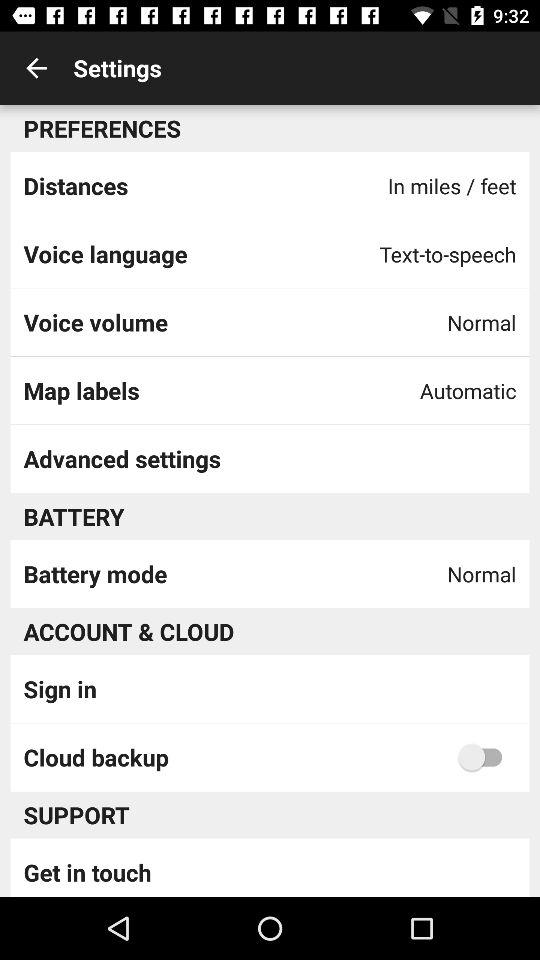What is the setting for voice volume? The setting for voice volume is "Normal". 